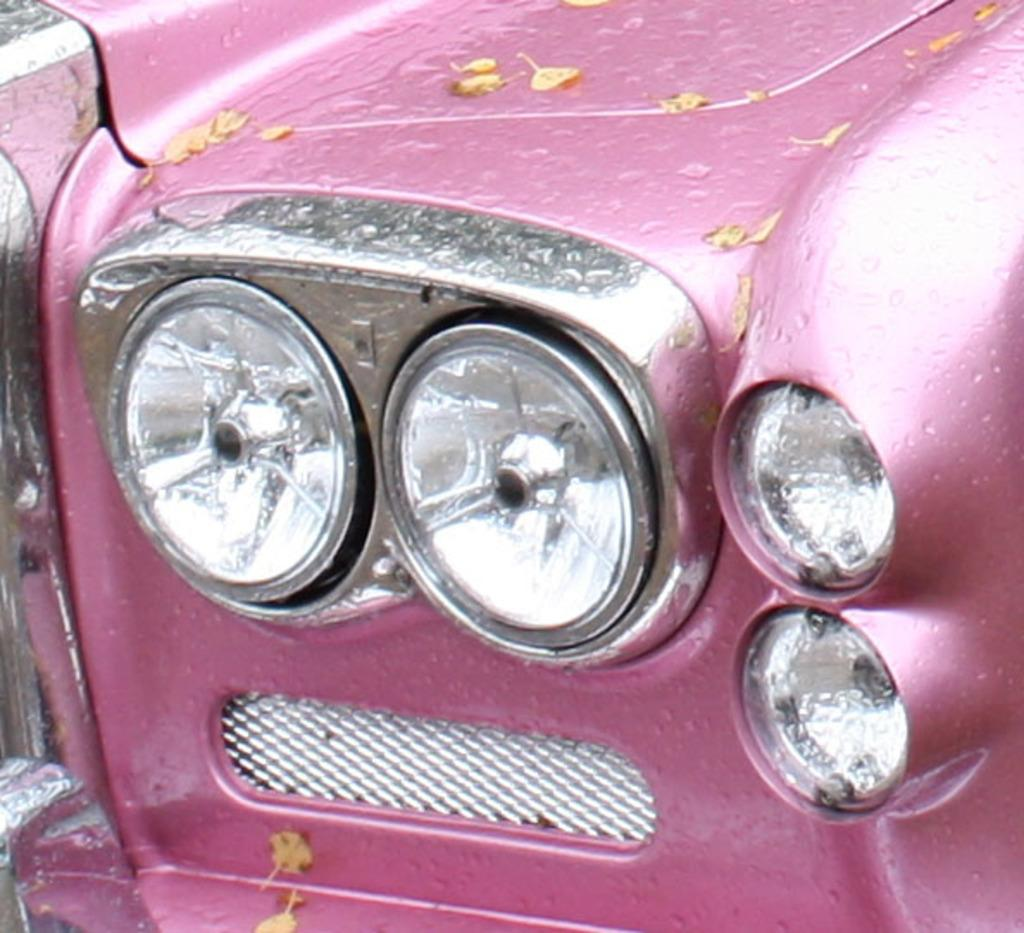What is the main subject of the image? The main subject of the image is a zoomed-in part of a vehicle. What can be said about the color of the vehicle? The vehicle is pink in color. How many oranges are visible on the quilt in the image? There are no oranges or quilts present in the image; it is a zoomed-in part of a pink vehicle. 